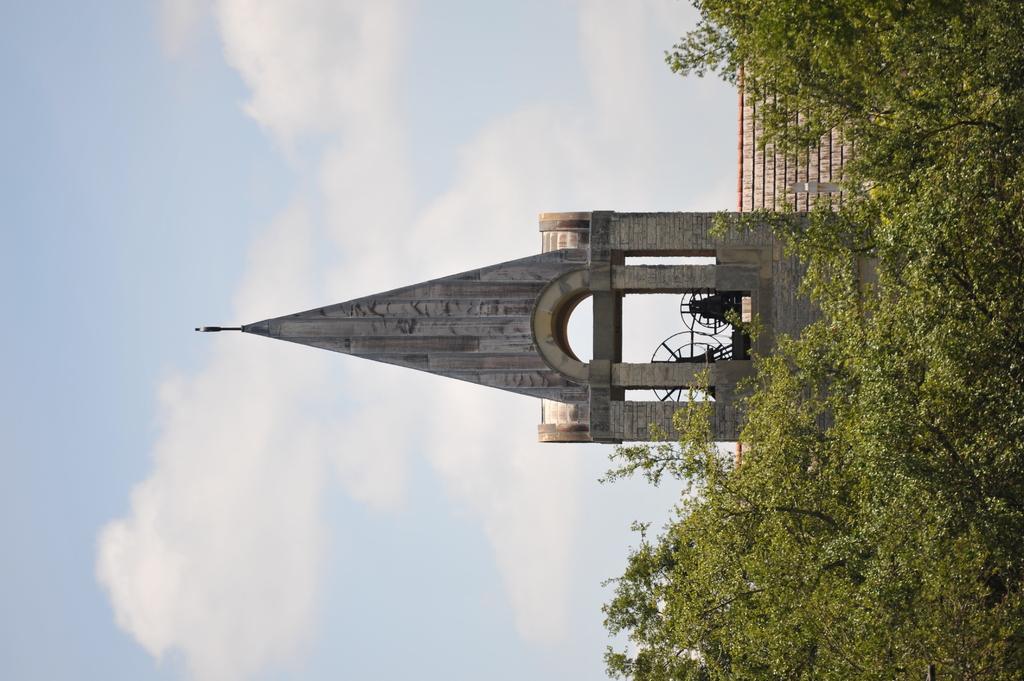How would you summarize this image in a sentence or two? In the image we can see a arc building, tree and a cloudy sky. 